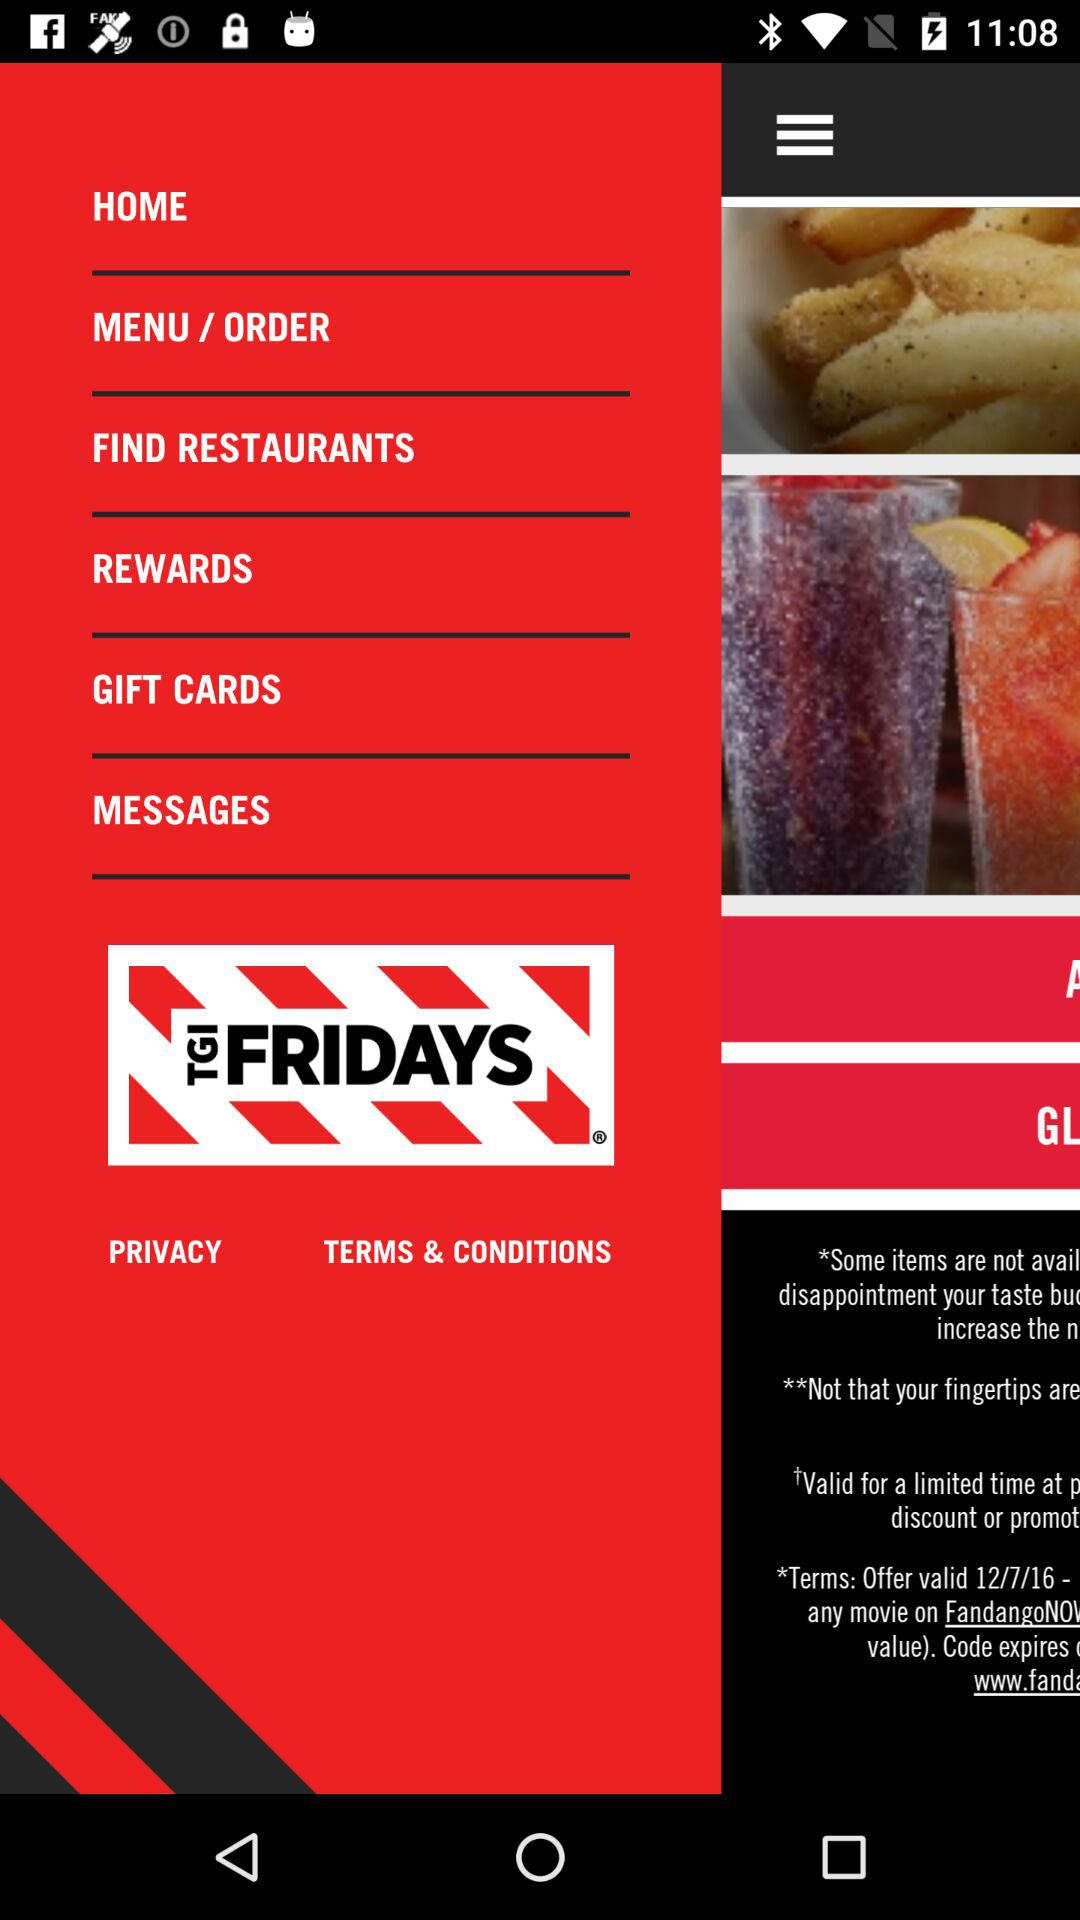What is the name of the application? The name of the application is "TGI FRIDAYS". 